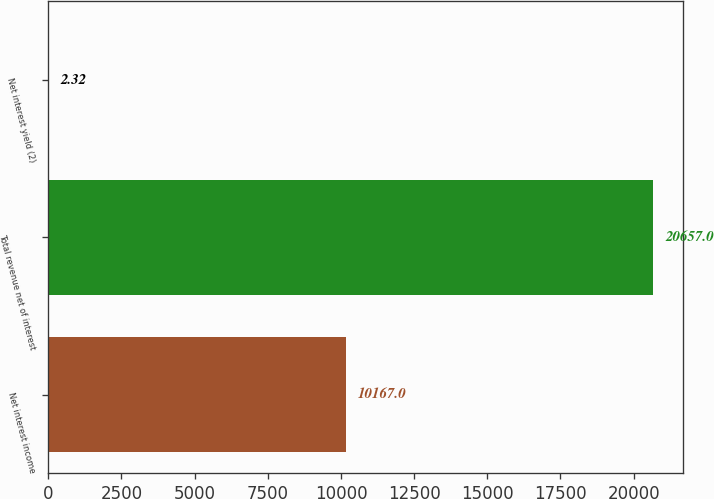Convert chart. <chart><loc_0><loc_0><loc_500><loc_500><bar_chart><fcel>Net interest income<fcel>Total revenue net of interest<fcel>Net interest yield (2)<nl><fcel>10167<fcel>20657<fcel>2.32<nl></chart> 